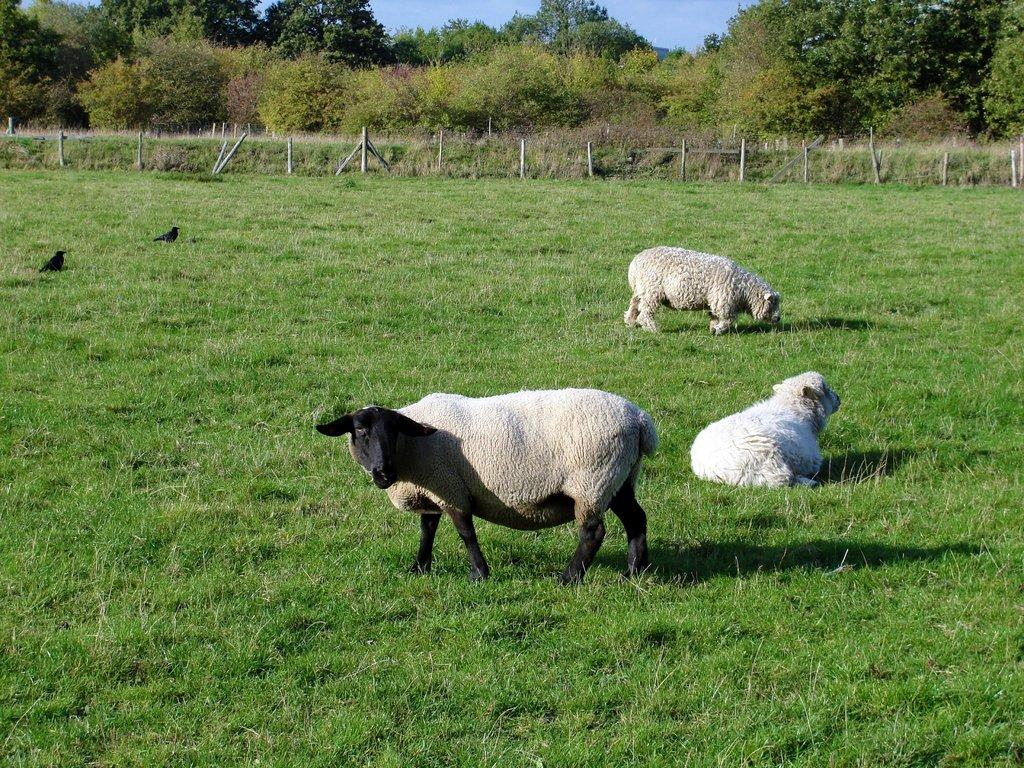How many animals can be seen in the image? There are three sheep and two birds in the image, making a total of five animals. What type of birds are on the ground in the image? The birds on the ground in the image are not specified, but they are present. What is visible in the background of the image? In the background of the image, there is a fence, trees, and the sky. When was the image taken? The image was taken during the day. What type of property is visible in the image? There is no property visible in the image; it primarily features animals and natural elements. Can you hear the bell ringing in the image? There is no bell present in the image, so it cannot be heard. 